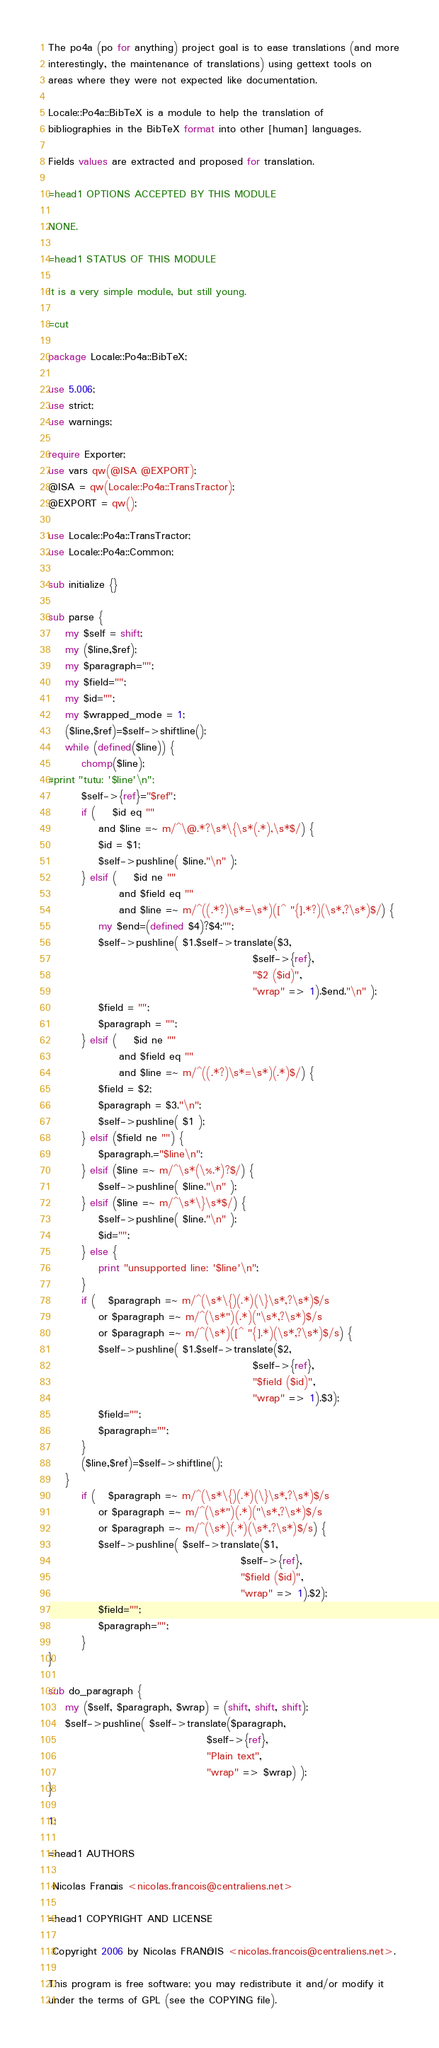<code> <loc_0><loc_0><loc_500><loc_500><_Perl_>
The po4a (po for anything) project goal is to ease translations (and more
interestingly, the maintenance of translations) using gettext tools on
areas where they were not expected like documentation.

Locale::Po4a::BibTeX is a module to help the translation of
bibliographies in the BibTeX format into other [human] languages.

Fields values are extracted and proposed for translation.

=head1 OPTIONS ACCEPTED BY THIS MODULE

NONE.

=head1 STATUS OF THIS MODULE

It is a very simple module, but still young.

=cut

package Locale::Po4a::BibTeX;

use 5.006;
use strict;
use warnings;

require Exporter;
use vars qw(@ISA @EXPORT);
@ISA = qw(Locale::Po4a::TransTractor);
@EXPORT = qw();

use Locale::Po4a::TransTractor;
use Locale::Po4a::Common;

sub initialize {}

sub parse {
    my $self = shift;
    my ($line,$ref);
    my $paragraph="";
    my $field="";
    my $id="";
    my $wrapped_mode = 1;
    ($line,$ref)=$self->shiftline();
    while (defined($line)) {
        chomp($line);
#print "tutu: '$line'\n";
        $self->{ref}="$ref";
        if (    $id eq ""
            and $line =~ m/^\@.*?\s*\{\s*(.*),\s*$/) {
            $id = $1;
            $self->pushline( $line."\n" );
        } elsif (    $id ne ""
                 and $field eq ""
                 and $line =~ m/^((.*?)\s*=\s*)([^ "{].*?)(\s*,?\s*)$/) {
            my $end=(defined $4)?$4:"";
            $self->pushline( $1.$self->translate($3,
                                                 $self->{ref},
                                                 "$2 ($id)",
                                                 "wrap" => 1).$end."\n" );
            $field = "";
            $paragraph = "";
        } elsif (    $id ne ""
                 and $field eq ""
                 and $line =~ m/^((.*?)\s*=\s*)(.*)$/) {
            $field = $2;
            $paragraph = $3."\n";
            $self->pushline( $1 );
        } elsif ($field ne "") {
            $paragraph.="$line\n";
        } elsif ($line =~ m/^\s*(\%.*)?$/) {
            $self->pushline( $line."\n" );
        } elsif ($line =~ m/^\s*\}\s*$/) {
            $self->pushline( $line."\n" );
            $id="";
        } else {
            print "unsupported line: '$line'\n";
        }
        if (   $paragraph =~ m/^(\s*\{)(.*)(\}\s*,?\s*)$/s
            or $paragraph =~ m/^(\s*")(.*)("\s*,?\s*)$/s
            or $paragraph =~ m/^(\s*)([^ "{].*)(\s*,?\s*)$/s) {
            $self->pushline( $1.$self->translate($2,
                                                 $self->{ref},
                                                 "$field ($id)",
                                                 "wrap" => 1).$3);
            $field="";
            $paragraph="";
        }
        ($line,$ref)=$self->shiftline();
    }
        if (   $paragraph =~ m/^(\s*\{)(.*)(\}\s*,?\s*)$/s
            or $paragraph =~ m/^(\s*")(.*)("\s*,?\s*)$/s
            or $paragraph =~ m/^(\s*)(.*)(\s*,?\s*)$/s) {
            $self->pushline( $self->translate($1,
                                              $self->{ref},
                                              "$field ($id)",
                                              "wrap" => 1).$2);
            $field="";
            $paragraph="";
        }
}

sub do_paragraph {
    my ($self, $paragraph, $wrap) = (shift, shift, shift);
    $self->pushline( $self->translate($paragraph,
                                      $self->{ref},
                                      "Plain text",
                                      "wrap" => $wrap) );
}

1;

=head1 AUTHORS

 Nicolas François <nicolas.francois@centraliens.net>

=head1 COPYRIGHT AND LICENSE

 Copyright 2006 by Nicolas FRANÇOIS <nicolas.francois@centraliens.net>.

This program is free software; you may redistribute it and/or modify it
under the terms of GPL (see the COPYING file).
</code> 